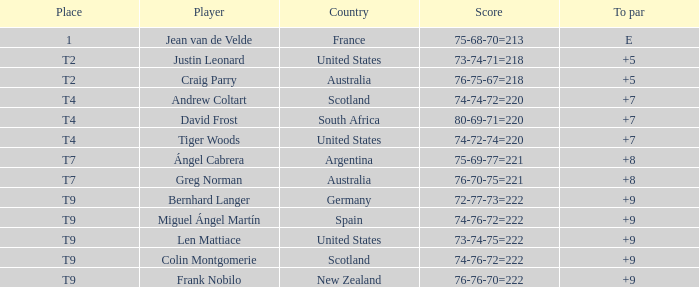During the event in which competitor david frost had a to par of +7, what was the final tally? 80-69-71=220. 